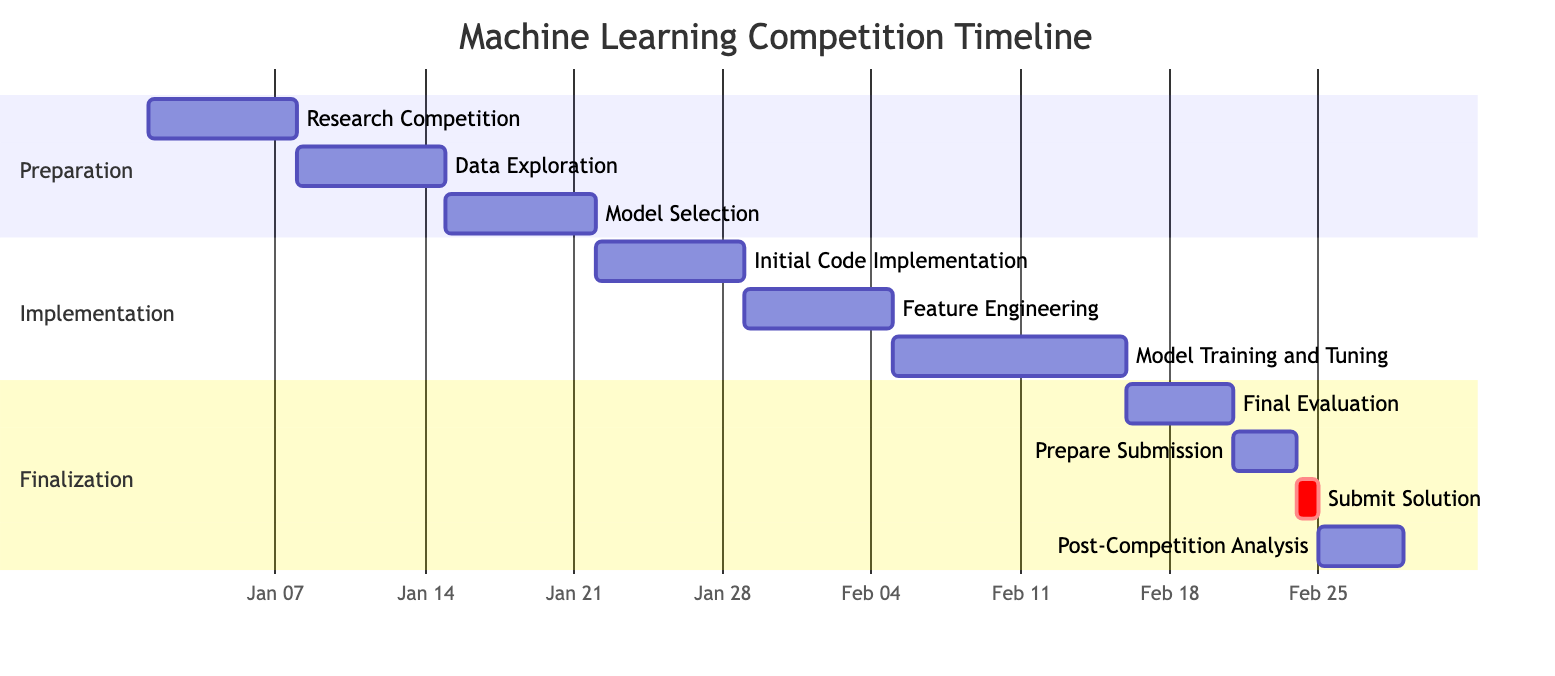What is the duration of the "Model Training and Tuning" phase? The "Model Training and Tuning" phase starts on February 5, 2024, and ends on February 15, 2024. This indicates a duration of 11 days in total.
Answer: 11 days Which task immediately follows "Data Exploration"? Looking at the diagram, the task titled "Model Selection" directly follows "Data Exploration," as it starts right after the completion of "Data Exploration" on January 15, 2024.
Answer: Model Selection How many days are allocated for the "Prepare Submission" task? The "Prepare Submission" task starts on February 21, 2024, and ends on February 23, 2024. This means it has a duration of 3 days specifically allocated for this task.
Answer: 3 days What is the start date of "Post-Competition Analysis"? The "Post-Competition Analysis" task begins on February 25, 2024, as indicated clearly in the diagram where this task is listed with its starting date.
Answer: February 25, 2024 In which section is "Feature Engineering" located? "Feature Engineering" is found in the "Implementation" section of the Gantt chart, as it lists this task alongside other related coding activities.
Answer: Implementation How many tasks are listed in the "Preparation" section? The "Preparation" section contains three distinct tasks: "Research Competition," "Data Exploration," and "Model Selection." Therefore, there are three tasks in total.
Answer: 3 tasks Which task has the earliest start date? The earliest start date belongs to the task "Research Competition," which begins on January 1, 2024, making it the first task in the timeline.
Answer: Research Competition What is notable about the "Submit Solution" task? The "Submit Solution" task is critical, as indicated by its priority designation (crit), and it occurs on February 24, 2024, making it the final activity before evaluation.
Answer: It is critical 